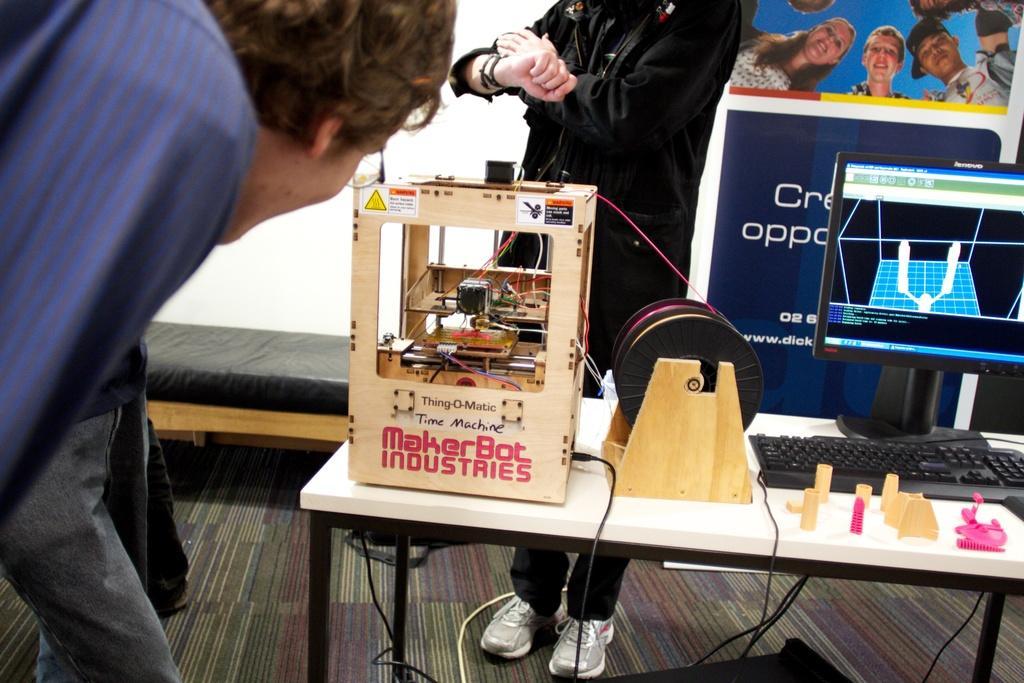Please provide a concise description of this image. In the image there is a desktop with keyboard and a 3d printer machine on a table, there are two men standing beside the table and one behind it, at the back there is a banner. 